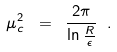Convert formula to latex. <formula><loc_0><loc_0><loc_500><loc_500>\mu _ { c } ^ { 2 } \ = \ \frac { 2 \pi } { \ln \frac { R } { \epsilon } } \ .</formula> 